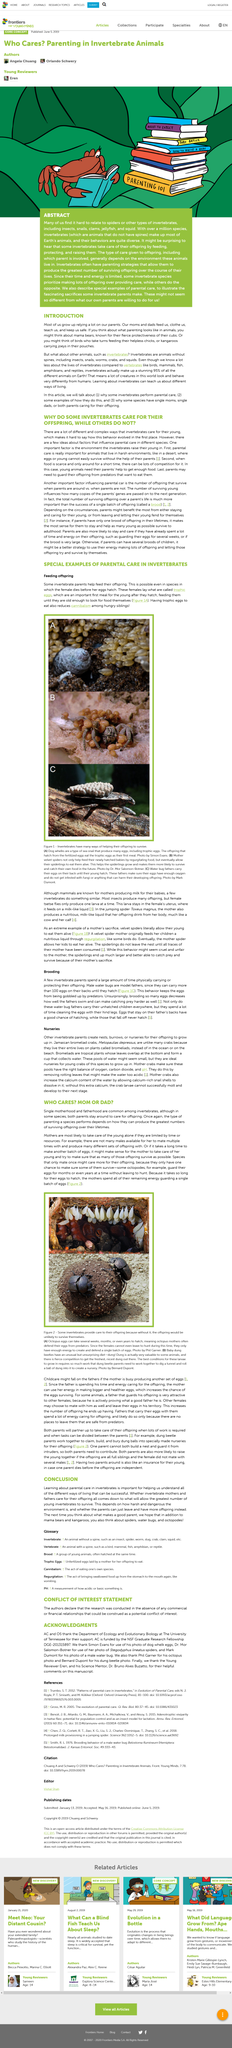Indicate a few pertinent items in this graphic. Figure 2 (A) displays octopus eggs. A brood refers to a single batch of offspring. Certain octopuses guard their eggs for extended periods, sometimes for months or even years. Single parenthood is a common phenomenon, especially among invertebrates. Trophic eggs have the potential to significantly reduce cannibalism among hungry siblings by providing a balanced and sustainable source of nutrients. 